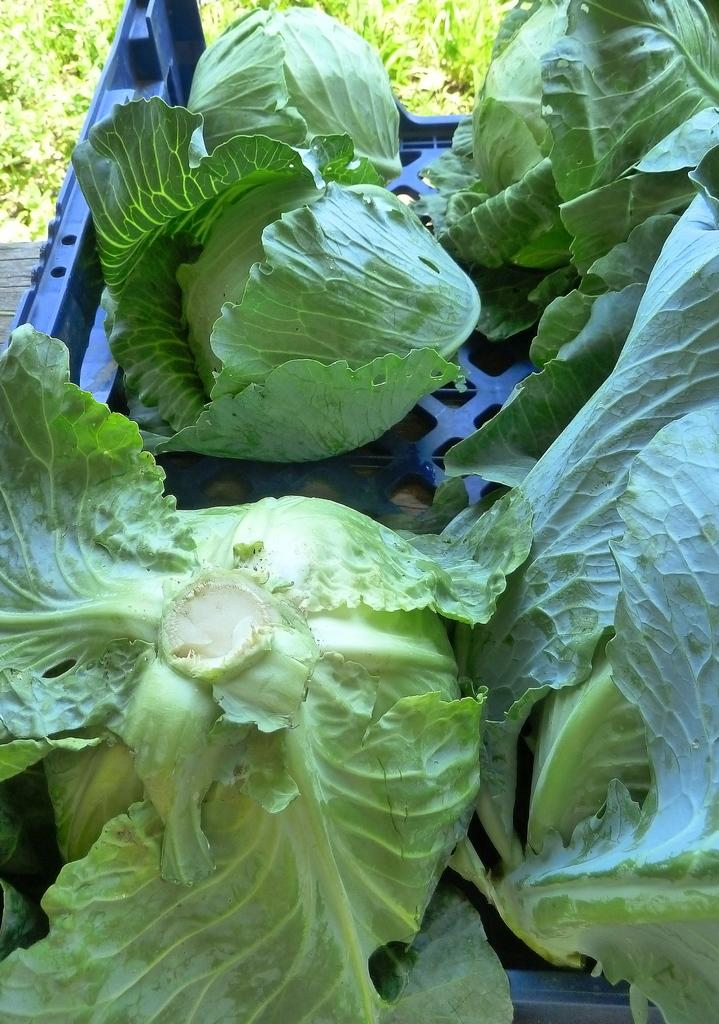What type of vegetables are in the tray in the image? There are cabbages in a tray in the image. What can be seen in the background of the image? There are trees in the background of the image. What type of ice can be seen melting on the cabbages in the image? There is no ice present on the cabbages in the image. What flavor of eggnog is being poured over the cabbages in the image? There is no eggnog present in the image; it features cabbages in a tray. 